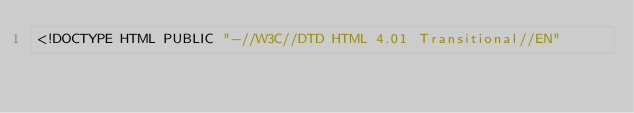Convert code to text. <code><loc_0><loc_0><loc_500><loc_500><_HTML_><!DOCTYPE HTML PUBLIC "-//W3C//DTD HTML 4.01 Transitional//EN"</code> 